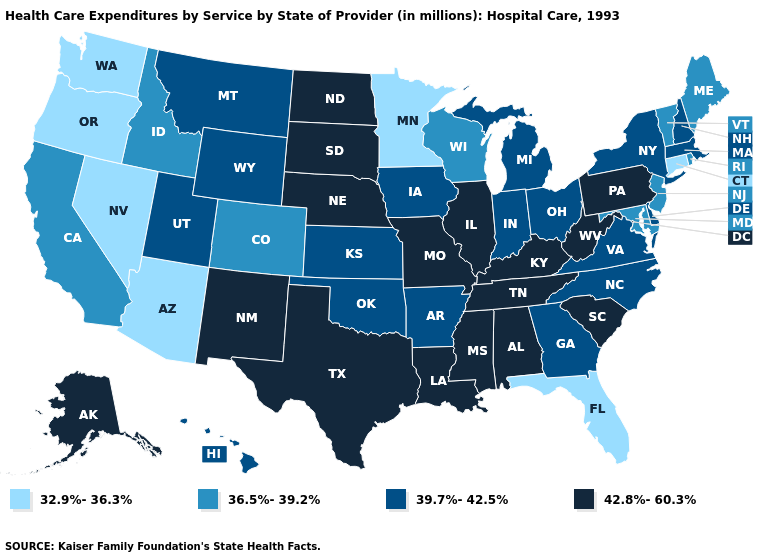Does Kentucky have the lowest value in the USA?
Answer briefly. No. Name the states that have a value in the range 42.8%-60.3%?
Be succinct. Alabama, Alaska, Illinois, Kentucky, Louisiana, Mississippi, Missouri, Nebraska, New Mexico, North Dakota, Pennsylvania, South Carolina, South Dakota, Tennessee, Texas, West Virginia. Does New York have the highest value in the USA?
Write a very short answer. No. What is the value of Vermont?
Give a very brief answer. 36.5%-39.2%. What is the lowest value in the MidWest?
Write a very short answer. 32.9%-36.3%. Which states have the highest value in the USA?
Write a very short answer. Alabama, Alaska, Illinois, Kentucky, Louisiana, Mississippi, Missouri, Nebraska, New Mexico, North Dakota, Pennsylvania, South Carolina, South Dakota, Tennessee, Texas, West Virginia. What is the lowest value in the USA?
Answer briefly. 32.9%-36.3%. Does Nevada have a lower value than New Hampshire?
Answer briefly. Yes. What is the value of Louisiana?
Be succinct. 42.8%-60.3%. Does Hawaii have the lowest value in the USA?
Short answer required. No. Name the states that have a value in the range 39.7%-42.5%?
Give a very brief answer. Arkansas, Delaware, Georgia, Hawaii, Indiana, Iowa, Kansas, Massachusetts, Michigan, Montana, New Hampshire, New York, North Carolina, Ohio, Oklahoma, Utah, Virginia, Wyoming. Among the states that border Delaware , which have the lowest value?
Answer briefly. Maryland, New Jersey. Name the states that have a value in the range 39.7%-42.5%?
Short answer required. Arkansas, Delaware, Georgia, Hawaii, Indiana, Iowa, Kansas, Massachusetts, Michigan, Montana, New Hampshire, New York, North Carolina, Ohio, Oklahoma, Utah, Virginia, Wyoming. Does Vermont have the same value as Alaska?
Quick response, please. No. Does the map have missing data?
Keep it brief. No. 